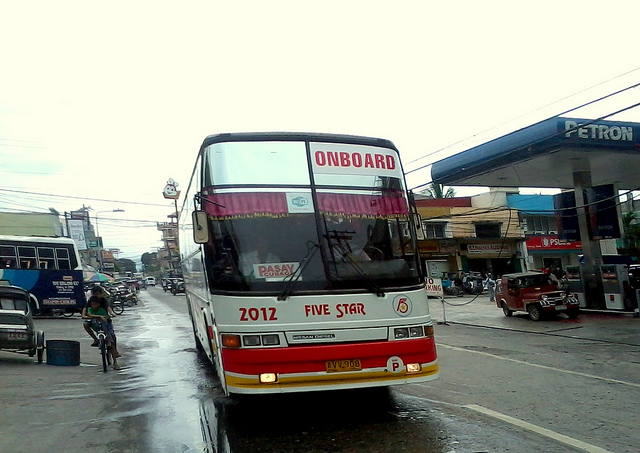<image>What kind of property is advertised to the left? I don't know what kind of property is advertised to the left. It can be a bus, storefront, commercial property or gas station. What kind of property is advertised to the left? It is ambiguous what kind of property is advertised to the left. It can be seen as a bus, storefront, or gas station. 